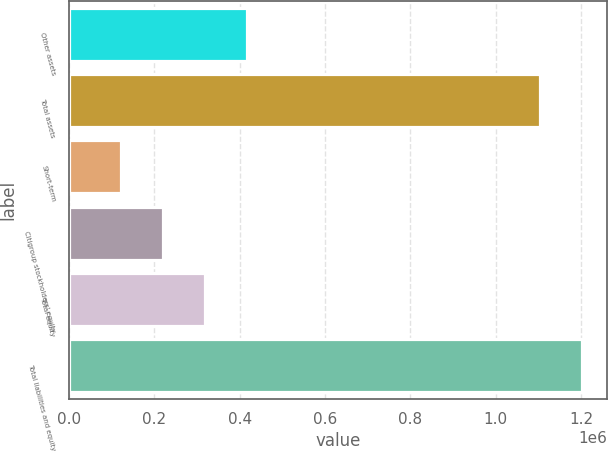<chart> <loc_0><loc_0><loc_500><loc_500><bar_chart><fcel>Other assets<fcel>Total assets<fcel>Short-term<fcel>Citigroup stockholders' equity<fcel>Total equity<fcel>Total liabilities and equity<nl><fcel>416838<fcel>1.10377e+06<fcel>122441<fcel>220574<fcel>318706<fcel>1.2019e+06<nl></chart> 